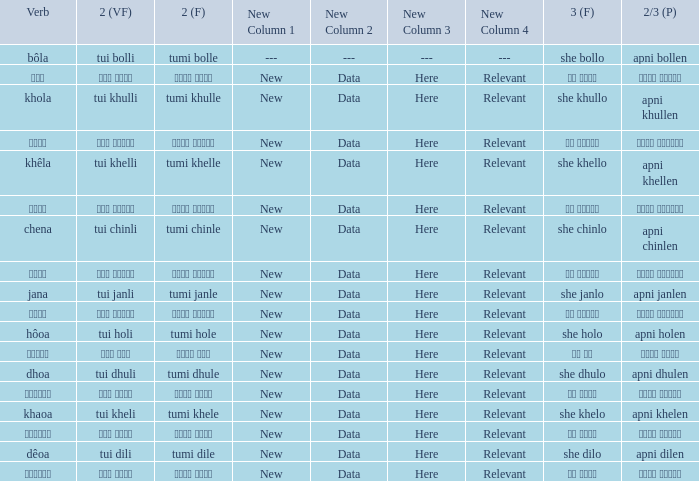What is the verb for তুমি খেলে? খাওয়া. 